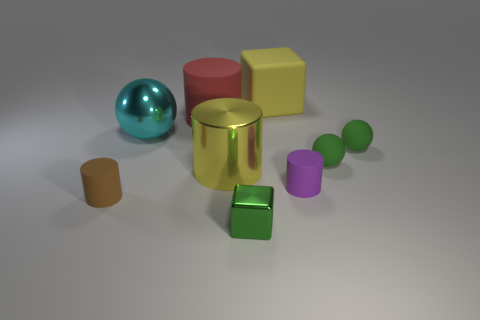Subtract 1 cylinders. How many cylinders are left? 3 Subtract all large red cylinders. How many cylinders are left? 3 Subtract all cyan cylinders. Subtract all yellow cubes. How many cylinders are left? 4 Add 1 tiny green things. How many objects exist? 10 Subtract all blocks. How many objects are left? 7 Subtract all brown matte cylinders. Subtract all red matte things. How many objects are left? 7 Add 8 small brown matte objects. How many small brown matte objects are left? 9 Add 7 large cubes. How many large cubes exist? 8 Subtract 0 purple blocks. How many objects are left? 9 